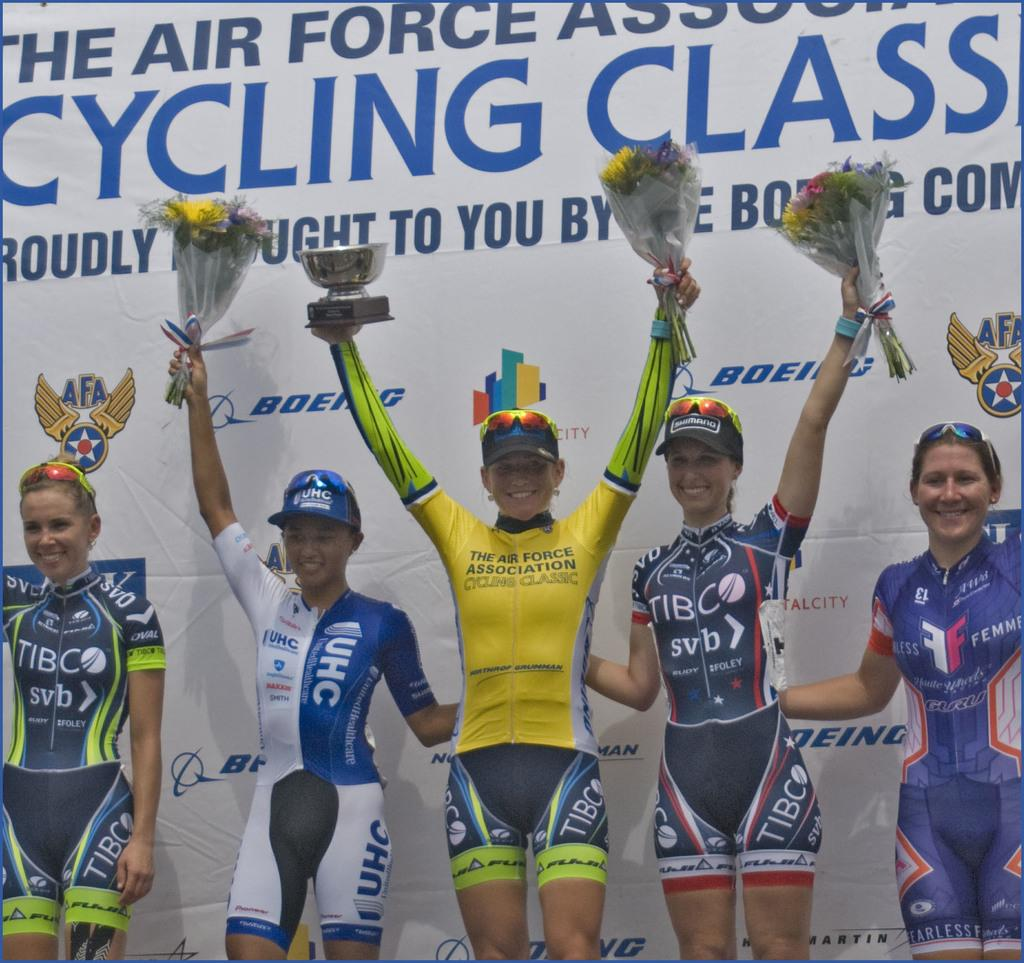<image>
Relay a brief, clear account of the picture shown. team members from the Air Force Association Cycling class holding flowers 